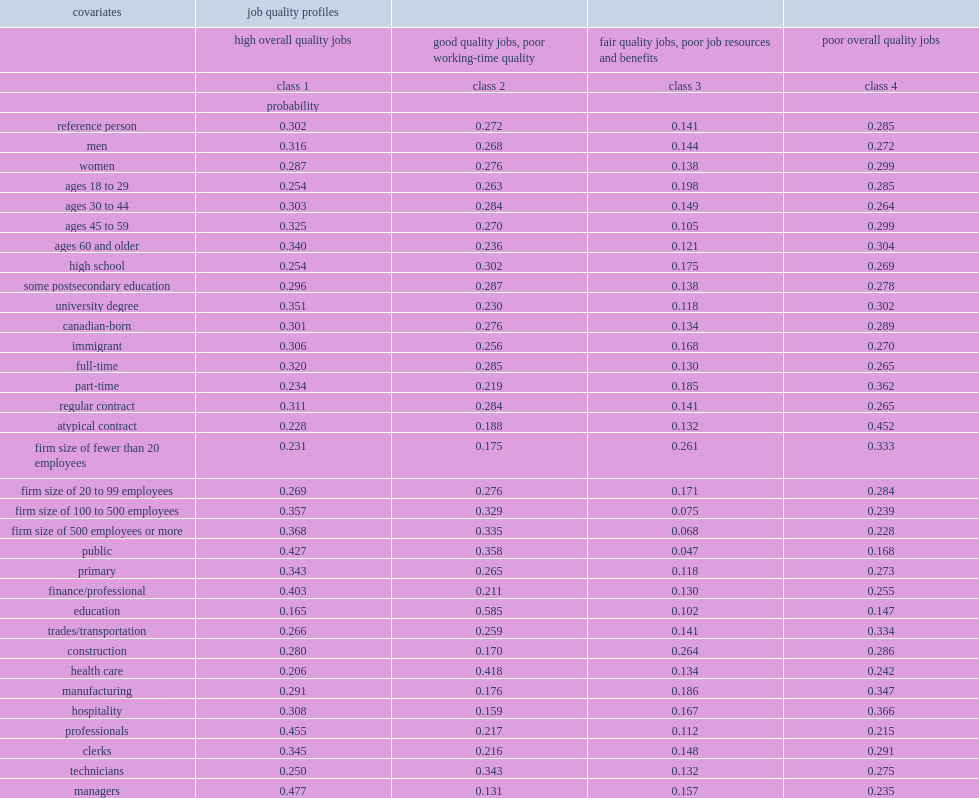What were the percentages of workers with a high school diploma predicted to be in class 1 and those university graduates respectively? 0.254 0.351. What was the percentage of atypical contract workers falling into the worst job quality class. 0.452. What was the percentage of atypical workers in the best class? 0.228. What was the percentage of workers in large firms (with 100 or more employees) predicted to be in the best- or good-quality classes? 0.725. What was the percentage of workers in small firms with fewer than 20 employees in the worst-job class? 0.333. 